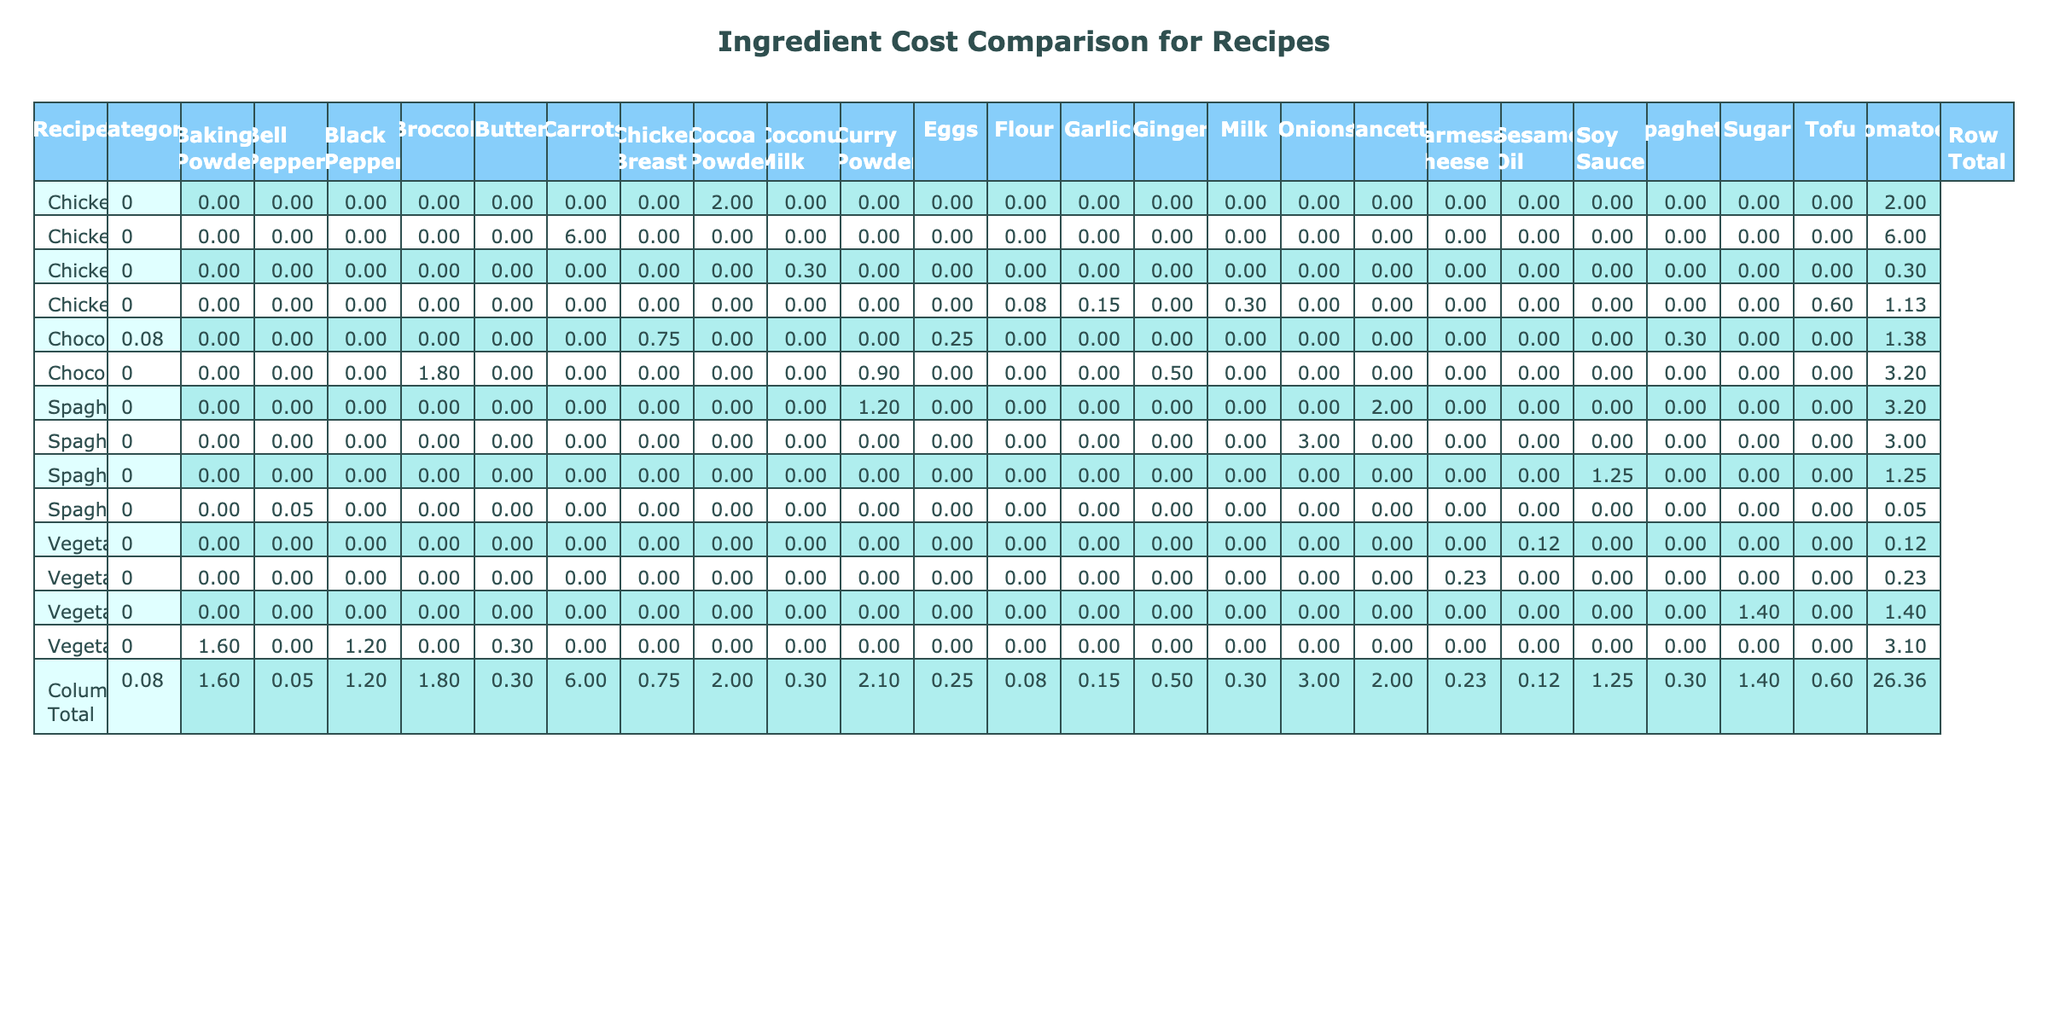What is the total cost of making a Chocolate Cake? To find this, we look at the row for Chocolate Cake and sum the Total Cost for all ingredients, which are Flour (0.25), Sugar (0.30), Cocoa Powder (0.75), Eggs (0.90), Butter (1.80), Milk (0.50), and Baking Powder (0.08). The total is 0.25 + 0.30 + 0.75 + 0.90 + 1.80 + 0.50 + 0.08 = 4.58.
Answer: 4.58 Which ingredient in Spaghetti Carbonara has the highest cost? In the Spaghetti Carbonara row, we compare the Total Costs of the ingredients: Spaghetti (1.25), Eggs (1.20), Pancetta (3.00), Parmesan Cheese (2.00), and Black Pepper (0.05). The highest cost is from Pancetta at 3.00.
Answer: Pancetta Is the total cost for Chicken Curry greater than the total cost for Spaghetti Carbonara? The total cost for Chicken Curry is 6.00 (Chicken Breast) + 0.30 (Onions) + 0.08 (Garlic) + 0.15 (Ginger) + 0.30 (Curry Powder) + 2.00 (Coconut Milk) + 0.60 (Tomatoes) = 9.43. For Spaghetti Carbonara, the total cost is 1.25 + 1.20 + 3.00 + 2.00 + 0.05 = 7.50. Since 9.43 > 7.50, the statement is true.
Answer: Yes What is the total cost of ingredients categorized as Dairy across all recipes? We identify the relevant ingredients from each of the recipes: Eggs (1.20 in Spaghetti Carbonara + 0.90 in Chocolate Cake = 2.10), Pancetta is Meat and does not count. For Dairy, we also have Parmesan Cheese (2.00 in Spaghetti Carbonara) and Coconut Milk (2.00 in Chicken Curry) plus Butter (1.80 in Chocolate Cake) and Milk (0.50 in Chocolate Cake). Thus, the total is 2.10 + 2.00 + 1.80 + 0.50 = 6.40.
Answer: 6.40 Is Tofu more expensive than Bell Peppers? Tofu in Vegetable Stir Fry costs 1.40, while Bell Peppers costs 1.60. Since 1.40 is less than 1.60, the statement is false.
Answer: No What is the average cost per ingredient for the Vegetable Stir Fry recipe? The total cost of ingredients in Vegetable Stir Fry is calculated as 1.60 (Bell Peppers) + 0.30 (Carrots) + 1.20 (Broccoli) + 0.12 (Soy Sauce) + 0.23 (Sesame Oil) + 1.40 (Tofu) = 4.95. There are 6 ingredients, thus the average is 4.95 / 6 = 0.825.
Answer: 0.83 Which recipe has the highest total cost? We compare the total costs: Spaghetti Carbonara (7.50), Chicken Curry (9.43), Vegetable Stir Fry (4.95), and Chocolate Cake (4.58). The maximum total cost is Chicken Curry at 9.43.
Answer: Chicken Curry What is the total cost of ingredients in the Baking category? The ingredients in the Baking category from the table are Flour (0.25), Sugar (0.30), Cocoa Powder (0.75), Eggs (0.90), Butter (1.80), and Baking Powder (0.08). The total cost adds up to 0.25 + 0.30 + 0.75 + 0.90 + 1.80 + 0.08 = 3.08.
Answer: 3.08 